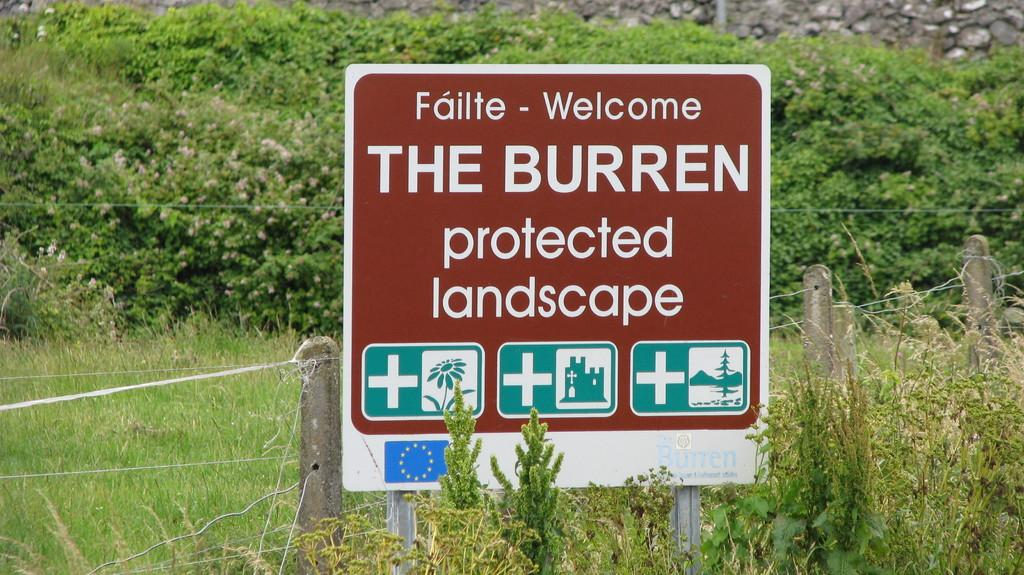<image>
Relay a brief, clear account of the picture shown. An outdoor sign with the words Welcome and The Burren protected landscape on it. 